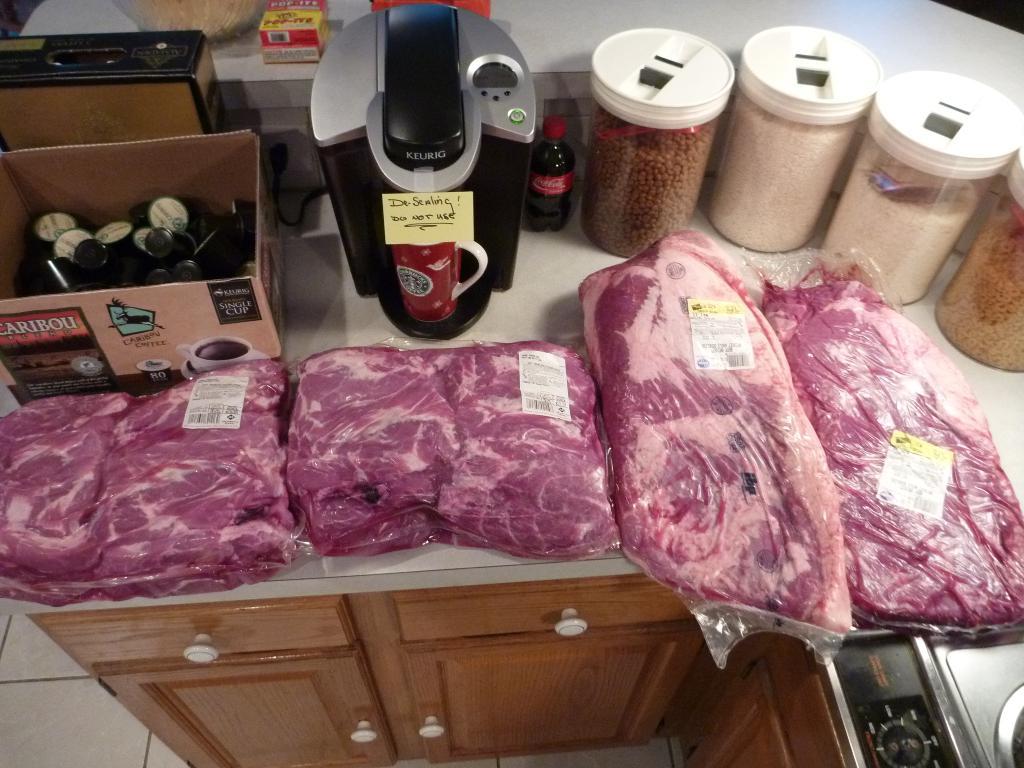The sticky note says the steling do not use?
Provide a succinct answer. Yes. 